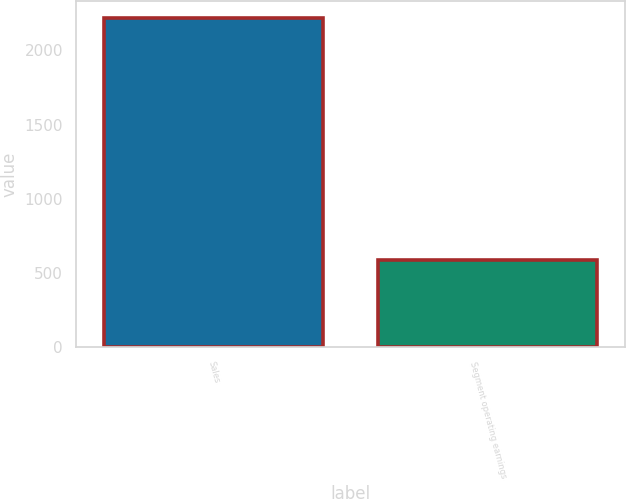Convert chart. <chart><loc_0><loc_0><loc_500><loc_500><bar_chart><fcel>Sales<fcel>Segment operating earnings<nl><fcel>2221.3<fcel>587.7<nl></chart> 